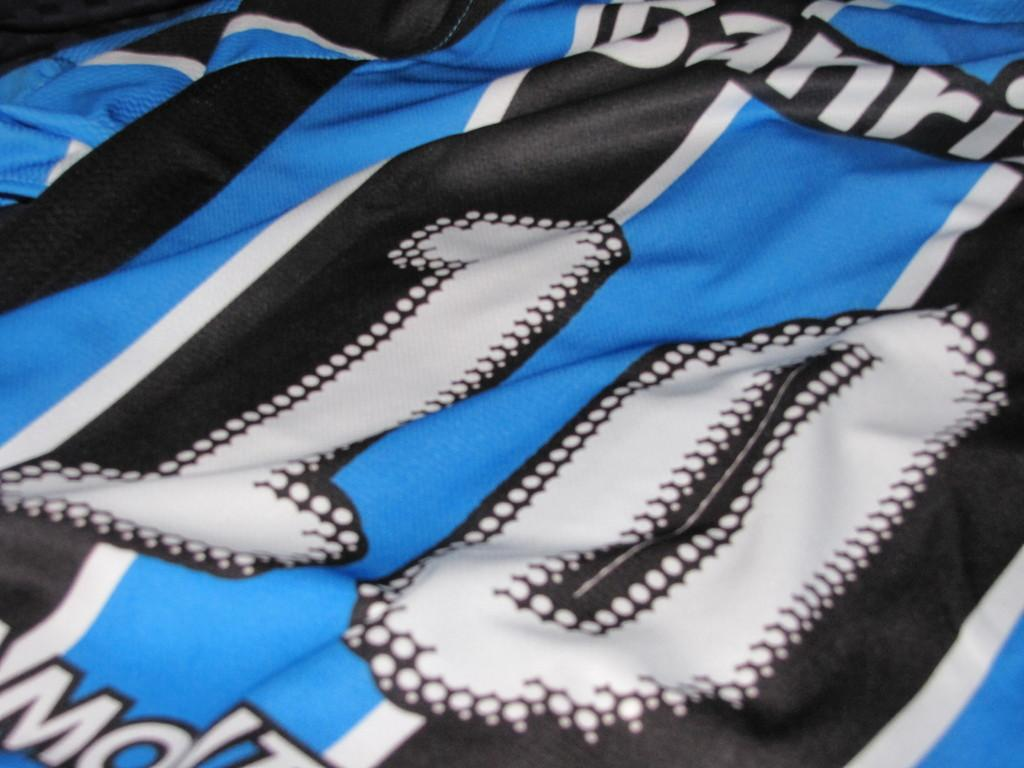<image>
Offer a succinct explanation of the picture presented. A blue, white and black sports jersey with the number 10 in white and outlined in black. 